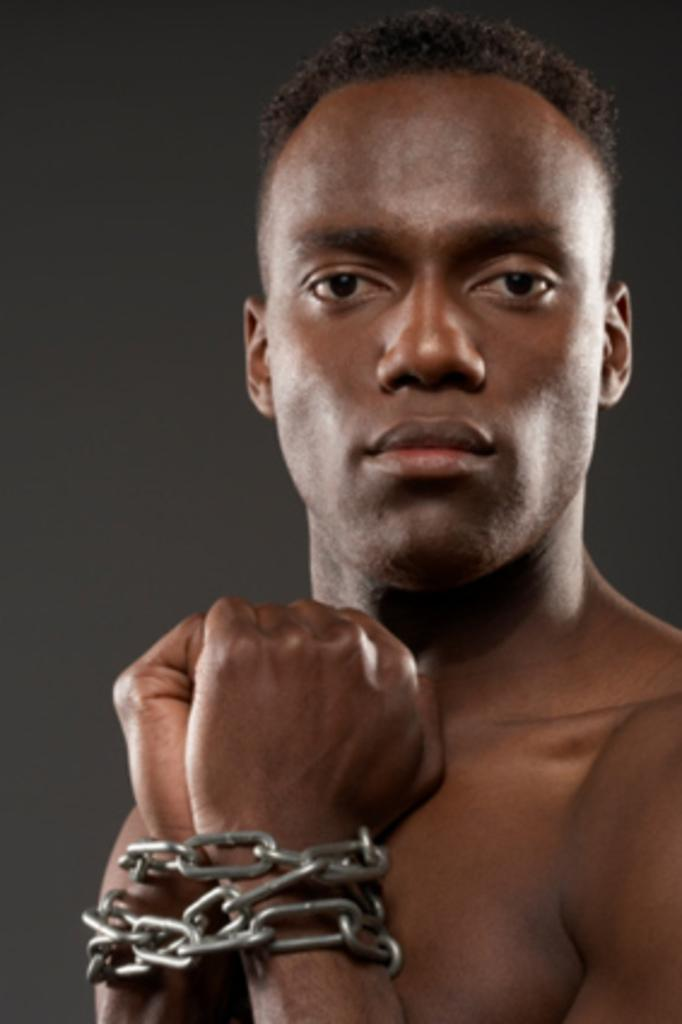What is the main subject of the image? There is a person in the image. What is happening to the person's hands in the image? The person's hands are tied with a metal chain. What color is the background of the image? The background of the image is black. What type of agreement did the clam sign with the secretary in the image? There is no clam or secretary present in the image, so no such agreement can be observed. 